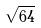Convert formula to latex. <formula><loc_0><loc_0><loc_500><loc_500>\sqrt { 6 4 }</formula> 